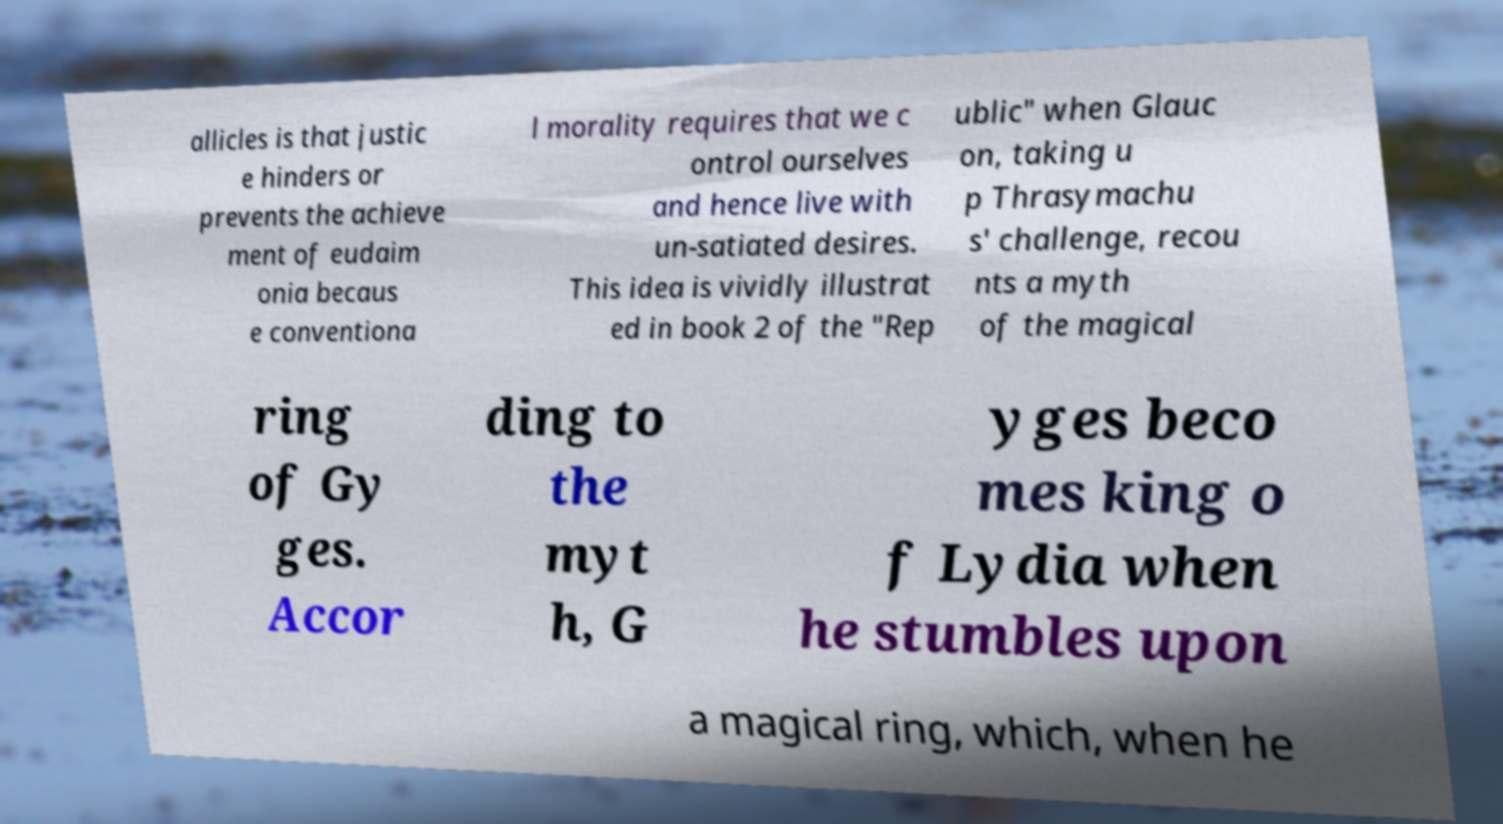Please read and relay the text visible in this image. What does it say? allicles is that justic e hinders or prevents the achieve ment of eudaim onia becaus e conventiona l morality requires that we c ontrol ourselves and hence live with un-satiated desires. This idea is vividly illustrat ed in book 2 of the "Rep ublic" when Glauc on, taking u p Thrasymachu s' challenge, recou nts a myth of the magical ring of Gy ges. Accor ding to the myt h, G yges beco mes king o f Lydia when he stumbles upon a magical ring, which, when he 